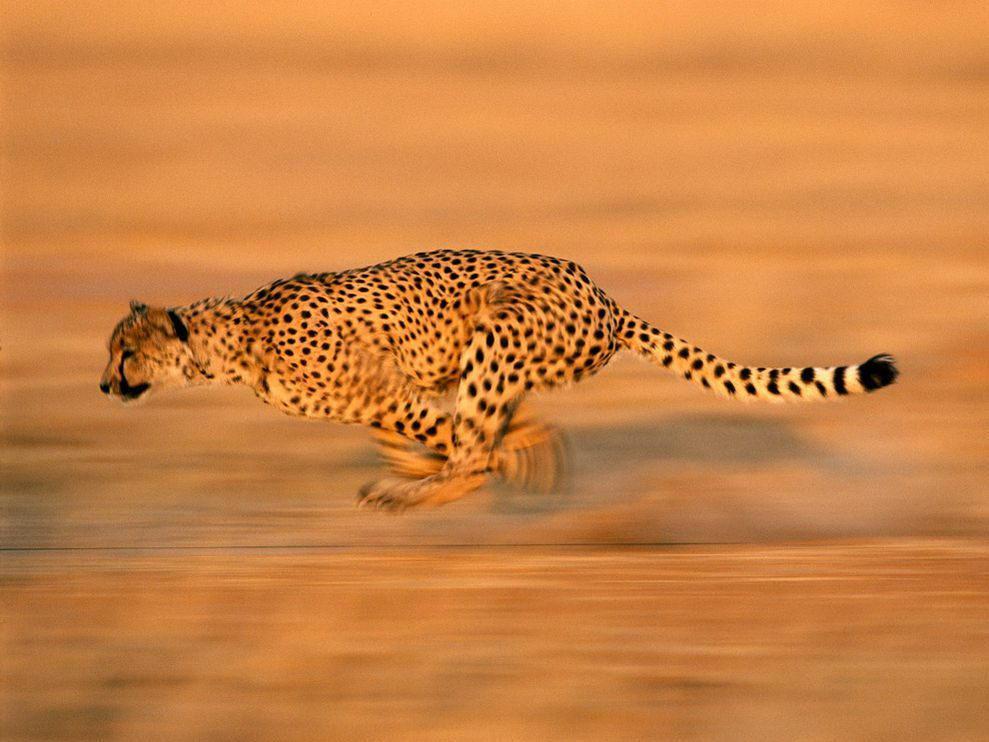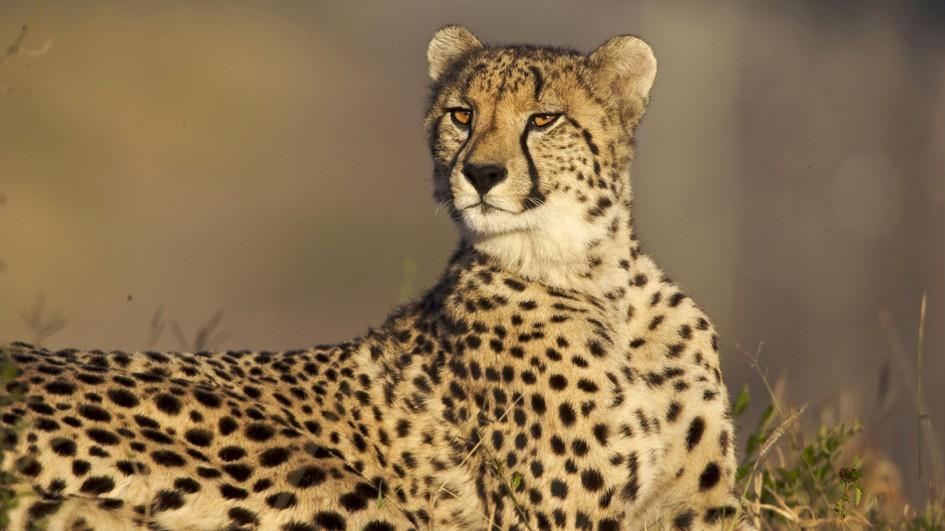The first image is the image on the left, the second image is the image on the right. Evaluate the accuracy of this statement regarding the images: "In one of the images there is a leopard lying on the ground.". Is it true? Answer yes or no. Yes. 